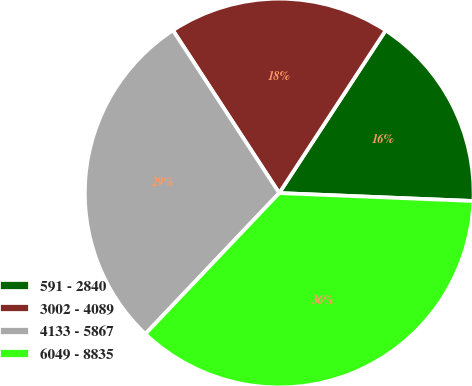Convert chart to OTSL. <chart><loc_0><loc_0><loc_500><loc_500><pie_chart><fcel>591 - 2840<fcel>3002 - 4089<fcel>4133 - 5867<fcel>6049 - 8835<nl><fcel>16.43%<fcel>18.43%<fcel>28.7%<fcel>36.44%<nl></chart> 